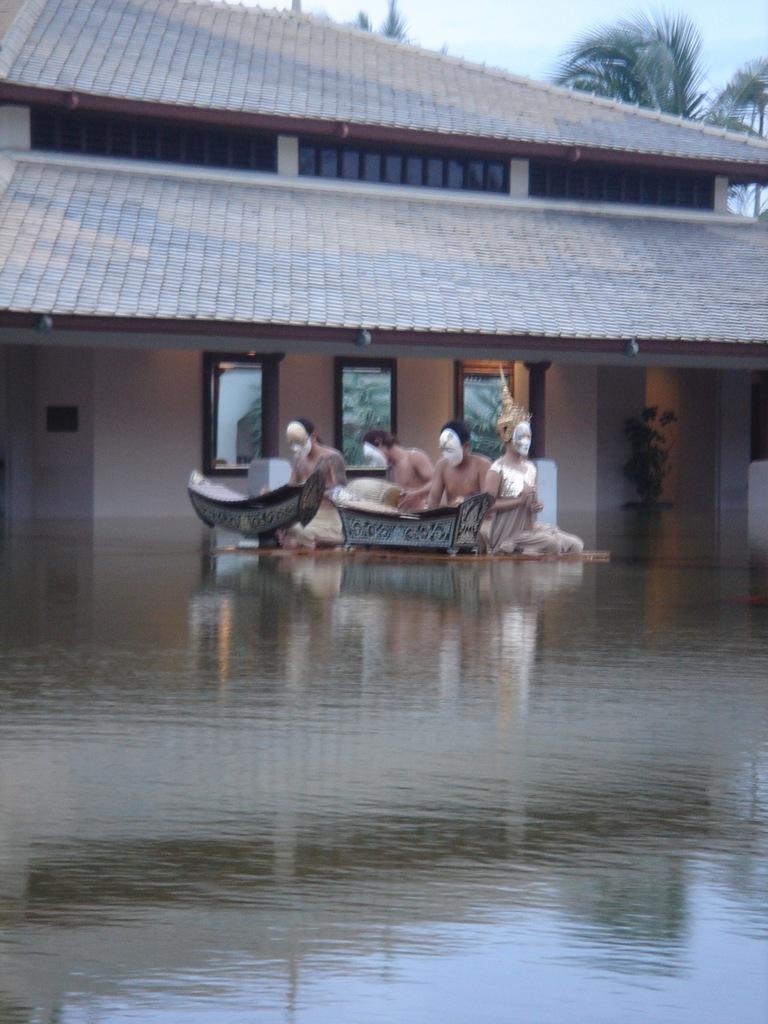How would you summarize this image in a sentence or two? In this picture we can see there are groups of people sitting on the path and in front of the people there is water and behind the people there is a houseplant, building, tree and a sky. 